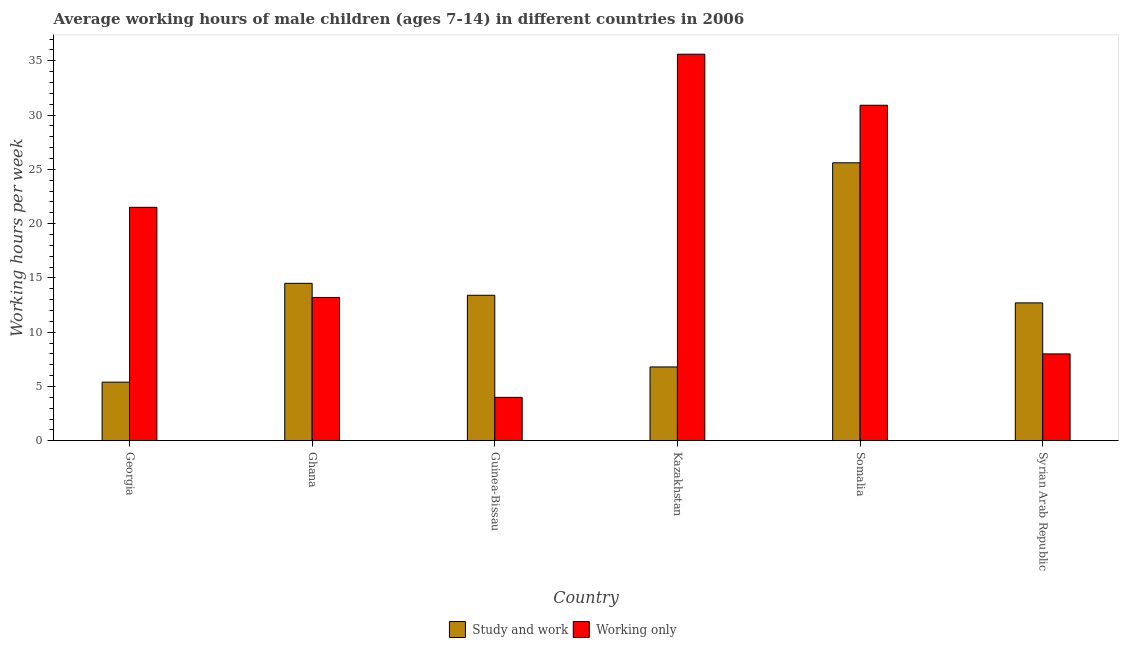How many different coloured bars are there?
Ensure brevity in your answer.  2. Are the number of bars per tick equal to the number of legend labels?
Ensure brevity in your answer.  Yes. How many bars are there on the 3rd tick from the left?
Give a very brief answer. 2. How many bars are there on the 5th tick from the right?
Give a very brief answer. 2. What is the label of the 6th group of bars from the left?
Make the answer very short. Syrian Arab Republic. What is the average working hour of children involved in only work in Kazakhstan?
Offer a terse response. 35.6. Across all countries, what is the maximum average working hour of children involved in only work?
Your answer should be compact. 35.6. In which country was the average working hour of children involved in study and work maximum?
Offer a terse response. Somalia. In which country was the average working hour of children involved in only work minimum?
Your answer should be very brief. Guinea-Bissau. What is the total average working hour of children involved in study and work in the graph?
Provide a short and direct response. 78.4. What is the difference between the average working hour of children involved in only work in Georgia and that in Guinea-Bissau?
Provide a succinct answer. 17.5. What is the difference between the average working hour of children involved in only work in Ghana and the average working hour of children involved in study and work in Somalia?
Ensure brevity in your answer.  -12.4. What is the average average working hour of children involved in study and work per country?
Make the answer very short. 13.07. What is the difference between the average working hour of children involved in study and work and average working hour of children involved in only work in Georgia?
Make the answer very short. -16.1. What is the ratio of the average working hour of children involved in only work in Guinea-Bissau to that in Kazakhstan?
Your response must be concise. 0.11. Is the average working hour of children involved in only work in Georgia less than that in Ghana?
Offer a terse response. No. What is the difference between the highest and the second highest average working hour of children involved in study and work?
Make the answer very short. 11.1. What is the difference between the highest and the lowest average working hour of children involved in only work?
Your answer should be compact. 31.6. In how many countries, is the average working hour of children involved in only work greater than the average average working hour of children involved in only work taken over all countries?
Make the answer very short. 3. Is the sum of the average working hour of children involved in only work in Guinea-Bissau and Kazakhstan greater than the maximum average working hour of children involved in study and work across all countries?
Your response must be concise. Yes. What does the 2nd bar from the left in Kazakhstan represents?
Offer a terse response. Working only. What does the 1st bar from the right in Ghana represents?
Ensure brevity in your answer.  Working only. How many bars are there?
Keep it short and to the point. 12. Are all the bars in the graph horizontal?
Provide a short and direct response. No. How many countries are there in the graph?
Make the answer very short. 6. Where does the legend appear in the graph?
Make the answer very short. Bottom center. How many legend labels are there?
Ensure brevity in your answer.  2. What is the title of the graph?
Provide a short and direct response. Average working hours of male children (ages 7-14) in different countries in 2006. Does "Urban" appear as one of the legend labels in the graph?
Offer a terse response. No. What is the label or title of the Y-axis?
Your answer should be very brief. Working hours per week. What is the Working hours per week of Working only in Georgia?
Provide a short and direct response. 21.5. What is the Working hours per week of Working only in Ghana?
Your answer should be very brief. 13.2. What is the Working hours per week of Working only in Guinea-Bissau?
Ensure brevity in your answer.  4. What is the Working hours per week in Working only in Kazakhstan?
Make the answer very short. 35.6. What is the Working hours per week of Study and work in Somalia?
Your answer should be very brief. 25.6. What is the Working hours per week in Working only in Somalia?
Ensure brevity in your answer.  30.9. What is the Working hours per week in Working only in Syrian Arab Republic?
Your answer should be compact. 8. Across all countries, what is the maximum Working hours per week of Study and work?
Make the answer very short. 25.6. Across all countries, what is the maximum Working hours per week of Working only?
Offer a terse response. 35.6. Across all countries, what is the minimum Working hours per week of Study and work?
Your answer should be very brief. 5.4. Across all countries, what is the minimum Working hours per week in Working only?
Give a very brief answer. 4. What is the total Working hours per week in Study and work in the graph?
Make the answer very short. 78.4. What is the total Working hours per week in Working only in the graph?
Ensure brevity in your answer.  113.2. What is the difference between the Working hours per week in Working only in Georgia and that in Ghana?
Ensure brevity in your answer.  8.3. What is the difference between the Working hours per week of Study and work in Georgia and that in Guinea-Bissau?
Your response must be concise. -8. What is the difference between the Working hours per week in Study and work in Georgia and that in Kazakhstan?
Ensure brevity in your answer.  -1.4. What is the difference between the Working hours per week of Working only in Georgia and that in Kazakhstan?
Offer a very short reply. -14.1. What is the difference between the Working hours per week of Study and work in Georgia and that in Somalia?
Ensure brevity in your answer.  -20.2. What is the difference between the Working hours per week in Working only in Georgia and that in Somalia?
Your answer should be very brief. -9.4. What is the difference between the Working hours per week of Study and work in Georgia and that in Syrian Arab Republic?
Make the answer very short. -7.3. What is the difference between the Working hours per week in Working only in Ghana and that in Guinea-Bissau?
Provide a succinct answer. 9.2. What is the difference between the Working hours per week in Working only in Ghana and that in Kazakhstan?
Your response must be concise. -22.4. What is the difference between the Working hours per week in Study and work in Ghana and that in Somalia?
Your answer should be very brief. -11.1. What is the difference between the Working hours per week of Working only in Ghana and that in Somalia?
Make the answer very short. -17.7. What is the difference between the Working hours per week in Study and work in Guinea-Bissau and that in Kazakhstan?
Your answer should be compact. 6.6. What is the difference between the Working hours per week in Working only in Guinea-Bissau and that in Kazakhstan?
Ensure brevity in your answer.  -31.6. What is the difference between the Working hours per week in Study and work in Guinea-Bissau and that in Somalia?
Offer a very short reply. -12.2. What is the difference between the Working hours per week of Working only in Guinea-Bissau and that in Somalia?
Ensure brevity in your answer.  -26.9. What is the difference between the Working hours per week of Working only in Guinea-Bissau and that in Syrian Arab Republic?
Provide a short and direct response. -4. What is the difference between the Working hours per week in Study and work in Kazakhstan and that in Somalia?
Give a very brief answer. -18.8. What is the difference between the Working hours per week of Working only in Kazakhstan and that in Somalia?
Make the answer very short. 4.7. What is the difference between the Working hours per week in Study and work in Kazakhstan and that in Syrian Arab Republic?
Provide a succinct answer. -5.9. What is the difference between the Working hours per week in Working only in Kazakhstan and that in Syrian Arab Republic?
Offer a terse response. 27.6. What is the difference between the Working hours per week of Working only in Somalia and that in Syrian Arab Republic?
Your response must be concise. 22.9. What is the difference between the Working hours per week in Study and work in Georgia and the Working hours per week in Working only in Ghana?
Provide a succinct answer. -7.8. What is the difference between the Working hours per week in Study and work in Georgia and the Working hours per week in Working only in Guinea-Bissau?
Your answer should be compact. 1.4. What is the difference between the Working hours per week of Study and work in Georgia and the Working hours per week of Working only in Kazakhstan?
Provide a short and direct response. -30.2. What is the difference between the Working hours per week of Study and work in Georgia and the Working hours per week of Working only in Somalia?
Give a very brief answer. -25.5. What is the difference between the Working hours per week in Study and work in Ghana and the Working hours per week in Working only in Guinea-Bissau?
Offer a terse response. 10.5. What is the difference between the Working hours per week of Study and work in Ghana and the Working hours per week of Working only in Kazakhstan?
Provide a short and direct response. -21.1. What is the difference between the Working hours per week of Study and work in Ghana and the Working hours per week of Working only in Somalia?
Your answer should be very brief. -16.4. What is the difference between the Working hours per week of Study and work in Ghana and the Working hours per week of Working only in Syrian Arab Republic?
Provide a succinct answer. 6.5. What is the difference between the Working hours per week of Study and work in Guinea-Bissau and the Working hours per week of Working only in Kazakhstan?
Provide a succinct answer. -22.2. What is the difference between the Working hours per week in Study and work in Guinea-Bissau and the Working hours per week in Working only in Somalia?
Provide a short and direct response. -17.5. What is the difference between the Working hours per week of Study and work in Guinea-Bissau and the Working hours per week of Working only in Syrian Arab Republic?
Offer a terse response. 5.4. What is the difference between the Working hours per week of Study and work in Kazakhstan and the Working hours per week of Working only in Somalia?
Give a very brief answer. -24.1. What is the difference between the Working hours per week in Study and work in Kazakhstan and the Working hours per week in Working only in Syrian Arab Republic?
Ensure brevity in your answer.  -1.2. What is the average Working hours per week in Study and work per country?
Provide a succinct answer. 13.07. What is the average Working hours per week in Working only per country?
Ensure brevity in your answer.  18.87. What is the difference between the Working hours per week of Study and work and Working hours per week of Working only in Georgia?
Make the answer very short. -16.1. What is the difference between the Working hours per week of Study and work and Working hours per week of Working only in Kazakhstan?
Ensure brevity in your answer.  -28.8. What is the difference between the Working hours per week in Study and work and Working hours per week in Working only in Somalia?
Your answer should be compact. -5.3. What is the ratio of the Working hours per week of Study and work in Georgia to that in Ghana?
Ensure brevity in your answer.  0.37. What is the ratio of the Working hours per week of Working only in Georgia to that in Ghana?
Give a very brief answer. 1.63. What is the ratio of the Working hours per week of Study and work in Georgia to that in Guinea-Bissau?
Your answer should be very brief. 0.4. What is the ratio of the Working hours per week in Working only in Georgia to that in Guinea-Bissau?
Make the answer very short. 5.38. What is the ratio of the Working hours per week of Study and work in Georgia to that in Kazakhstan?
Your answer should be compact. 0.79. What is the ratio of the Working hours per week of Working only in Georgia to that in Kazakhstan?
Ensure brevity in your answer.  0.6. What is the ratio of the Working hours per week of Study and work in Georgia to that in Somalia?
Keep it short and to the point. 0.21. What is the ratio of the Working hours per week of Working only in Georgia to that in Somalia?
Provide a succinct answer. 0.7. What is the ratio of the Working hours per week in Study and work in Georgia to that in Syrian Arab Republic?
Provide a short and direct response. 0.43. What is the ratio of the Working hours per week of Working only in Georgia to that in Syrian Arab Republic?
Your answer should be compact. 2.69. What is the ratio of the Working hours per week of Study and work in Ghana to that in Guinea-Bissau?
Offer a very short reply. 1.08. What is the ratio of the Working hours per week of Working only in Ghana to that in Guinea-Bissau?
Provide a succinct answer. 3.3. What is the ratio of the Working hours per week in Study and work in Ghana to that in Kazakhstan?
Make the answer very short. 2.13. What is the ratio of the Working hours per week of Working only in Ghana to that in Kazakhstan?
Offer a terse response. 0.37. What is the ratio of the Working hours per week in Study and work in Ghana to that in Somalia?
Keep it short and to the point. 0.57. What is the ratio of the Working hours per week in Working only in Ghana to that in Somalia?
Give a very brief answer. 0.43. What is the ratio of the Working hours per week in Study and work in Ghana to that in Syrian Arab Republic?
Your response must be concise. 1.14. What is the ratio of the Working hours per week of Working only in Ghana to that in Syrian Arab Republic?
Offer a very short reply. 1.65. What is the ratio of the Working hours per week of Study and work in Guinea-Bissau to that in Kazakhstan?
Keep it short and to the point. 1.97. What is the ratio of the Working hours per week of Working only in Guinea-Bissau to that in Kazakhstan?
Your answer should be very brief. 0.11. What is the ratio of the Working hours per week in Study and work in Guinea-Bissau to that in Somalia?
Offer a very short reply. 0.52. What is the ratio of the Working hours per week in Working only in Guinea-Bissau to that in Somalia?
Provide a short and direct response. 0.13. What is the ratio of the Working hours per week of Study and work in Guinea-Bissau to that in Syrian Arab Republic?
Provide a succinct answer. 1.06. What is the ratio of the Working hours per week of Working only in Guinea-Bissau to that in Syrian Arab Republic?
Your answer should be very brief. 0.5. What is the ratio of the Working hours per week of Study and work in Kazakhstan to that in Somalia?
Provide a short and direct response. 0.27. What is the ratio of the Working hours per week in Working only in Kazakhstan to that in Somalia?
Offer a terse response. 1.15. What is the ratio of the Working hours per week in Study and work in Kazakhstan to that in Syrian Arab Republic?
Your response must be concise. 0.54. What is the ratio of the Working hours per week of Working only in Kazakhstan to that in Syrian Arab Republic?
Give a very brief answer. 4.45. What is the ratio of the Working hours per week in Study and work in Somalia to that in Syrian Arab Republic?
Provide a short and direct response. 2.02. What is the ratio of the Working hours per week in Working only in Somalia to that in Syrian Arab Republic?
Offer a very short reply. 3.86. What is the difference between the highest and the second highest Working hours per week in Study and work?
Provide a short and direct response. 11.1. What is the difference between the highest and the lowest Working hours per week in Study and work?
Provide a short and direct response. 20.2. What is the difference between the highest and the lowest Working hours per week in Working only?
Your answer should be compact. 31.6. 